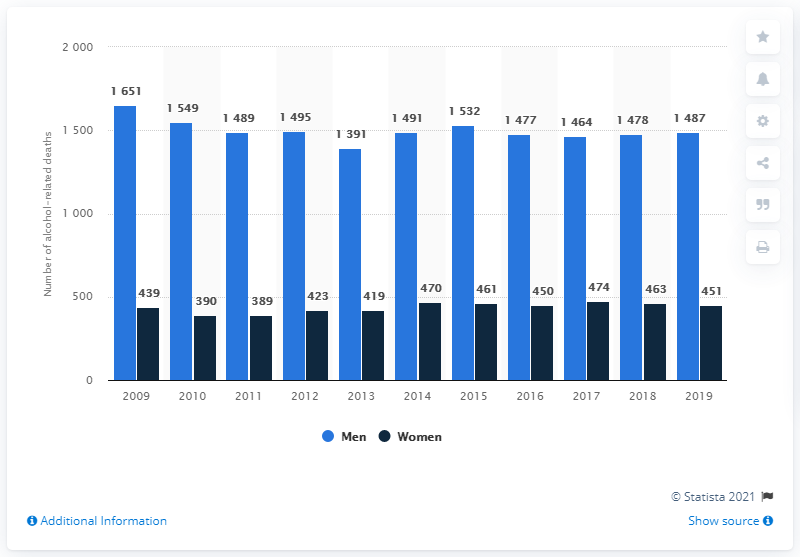Specify some key components in this picture. There were 451 cases of alcohol-related deaths among women in Sweden in 2019. 